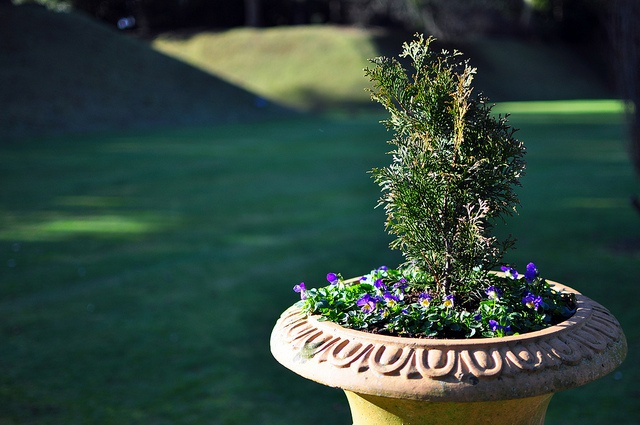Describe the objects in this image and their specific colors. I can see potted plant in black, ivory, gray, and darkgreen tones and vase in black, ivory, tan, and maroon tones in this image. 